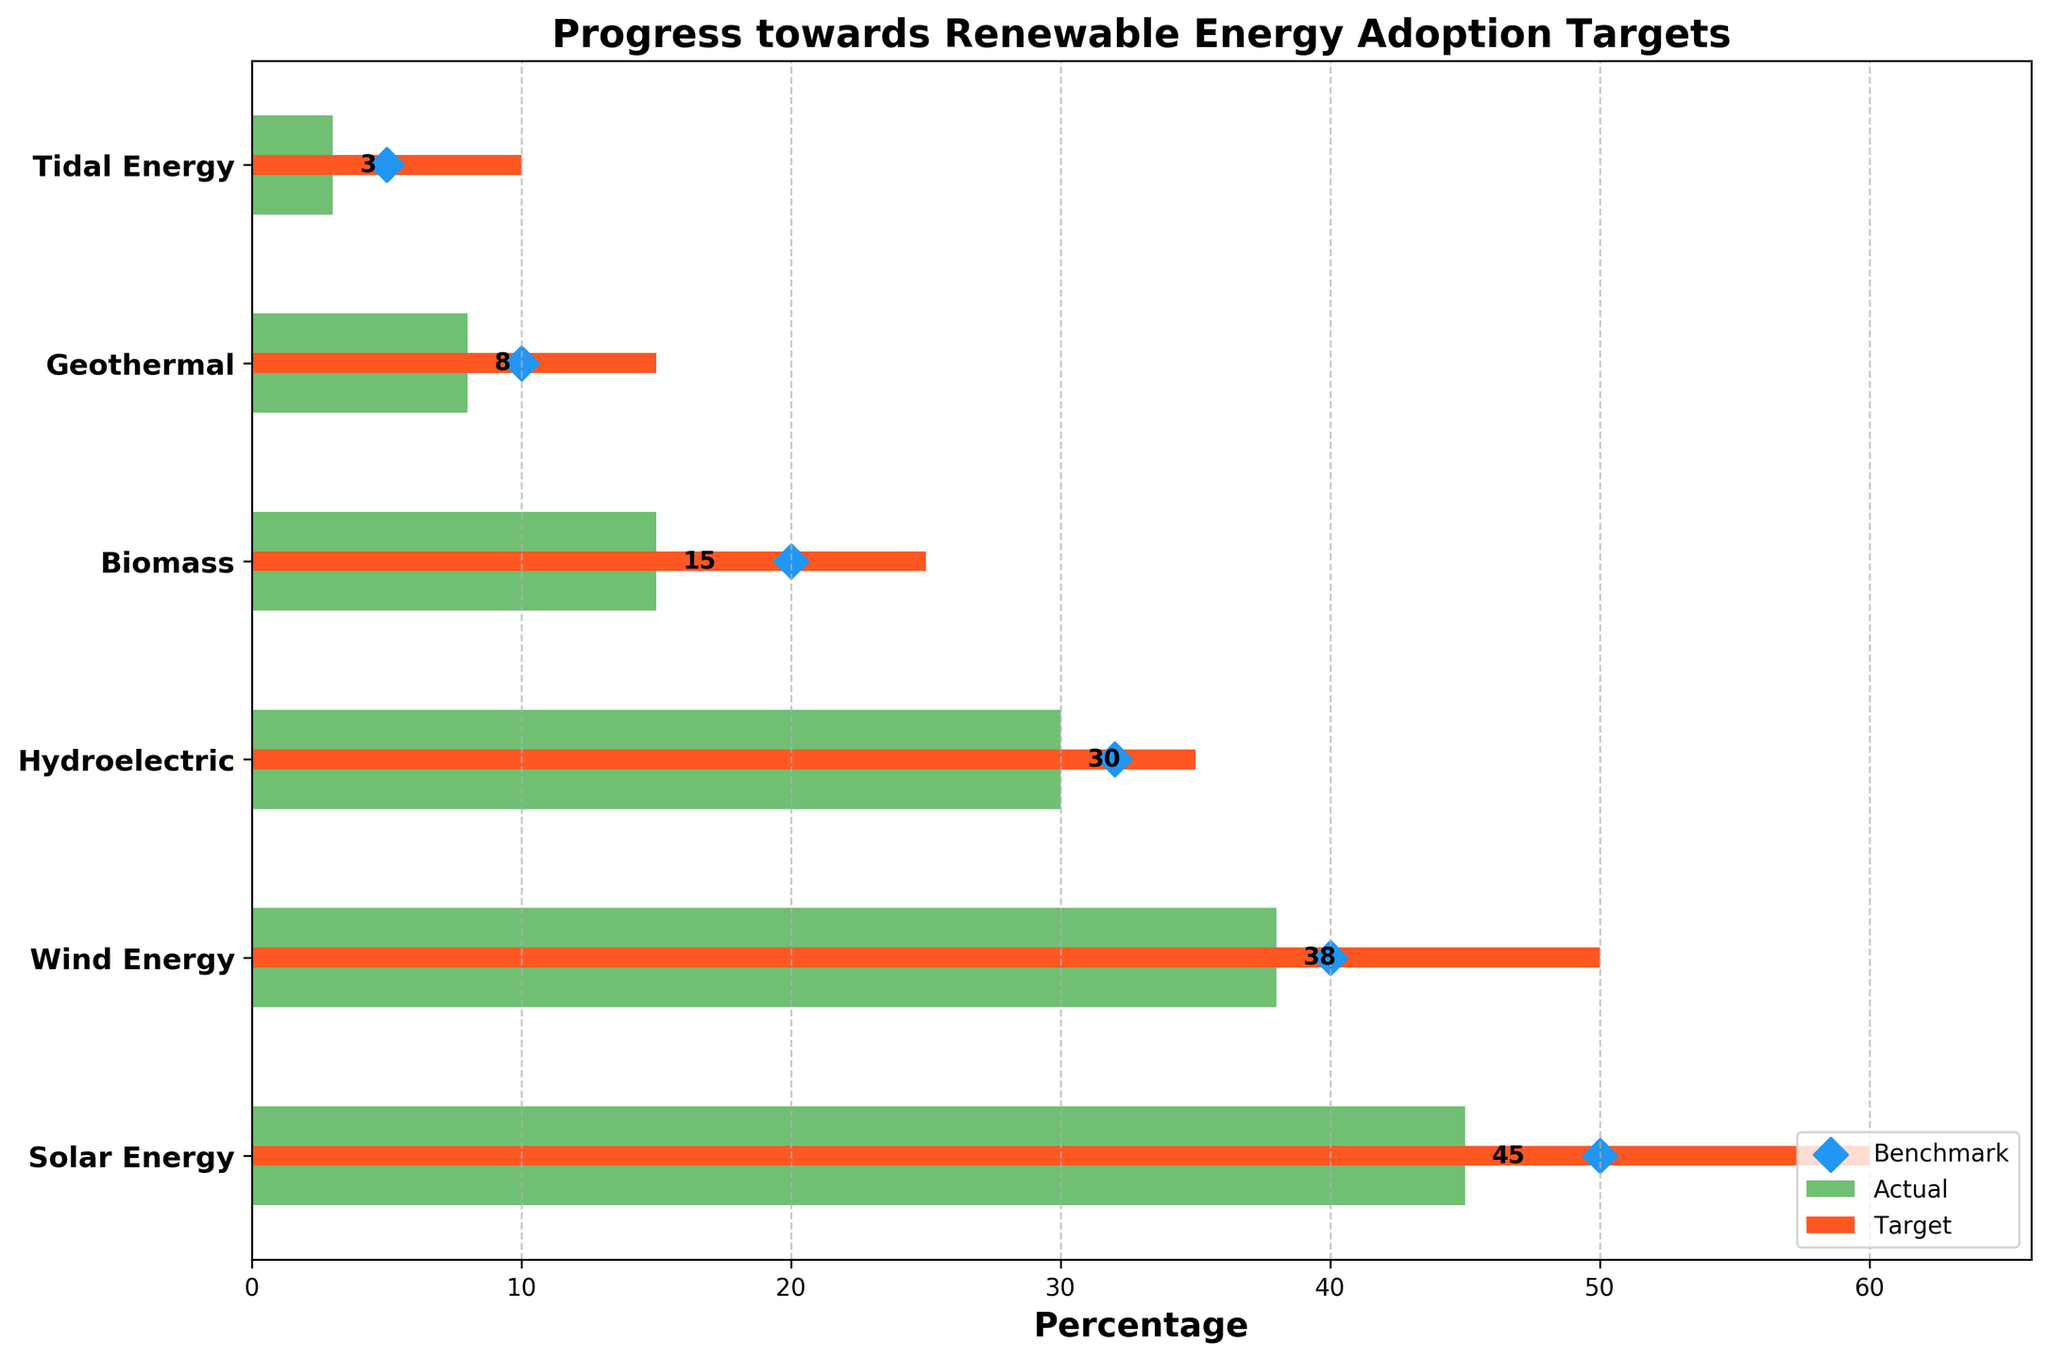What's the title of the figure? The title is located at the top of the figure in a larger and bold font, making it easy to identify.
Answer: Progress towards Renewable Energy Adoption Targets What is the actual percentage for Biomass energy? Locate the bar representing Biomass and find the label or the length of the bar. The actual value is written at the end of the bar.
Answer: 15 Which renewable energy type has the highest target percentage? To find the highest target, look for the category with the longest orange bar (target value).
Answer: Solar Energy What are the benchmark values for Wind Energy and Geothermal energy? Locate the diamond markers on the y-axis corresponding to Wind Energy and Geothermal energy categories. The Wind Energy marker is at 40, and the Geothermal marker is at 10.
Answer: 40 and 10 Is the actual percentage for Solar Energy higher than its benchmark? Compare the length of the green bar for Solar Energy (actual) with the position of the blue diamond marker (benchmark). The actual value (45) is lower than the benchmark (50).
Answer: No How many renewable energy types have actual percentages below their benchmarks? Compare the green bars (actual) with the blue diamond markers (benchmark) for each category. Count the instances where the actual value is less than the benchmark value. 4 categories meet this criteria: Solar Energy, Wind Energy, Geothermal, and Tidal Energy.
Answer: 4 What is the difference between the target and actual percentages for Tidal Energy? Identify the lengths of the orange bar (target) and the green bar (actual) corresponding to Tidal Energy. Subtract the actual value from the target value: 10 - 3.
Answer: 7 Which renewable energy type is closest to reaching its target percentage? Compare the difference between the target (orange bar) and the actual value (green bar) for each category. The smallest difference is for Hydroelectric energy: 35 - 30.
Answer: Hydroelectric Are any renewable energy types exceeding their benchmarks? Check if any green bars (actual) extend beyond their respective blue diamond markers (benchmark). The actual values for Hydroelectric (30 vs. 32) and Biomass (15 vs. 20) do not exceed their benchmarks.
Answer: No Which renewable energy category has the smallest actual percentage? Compare the lengths of the green bars (actual) for all categories. The shortest bar is for Tidal Energy.
Answer: Tidal Energy 